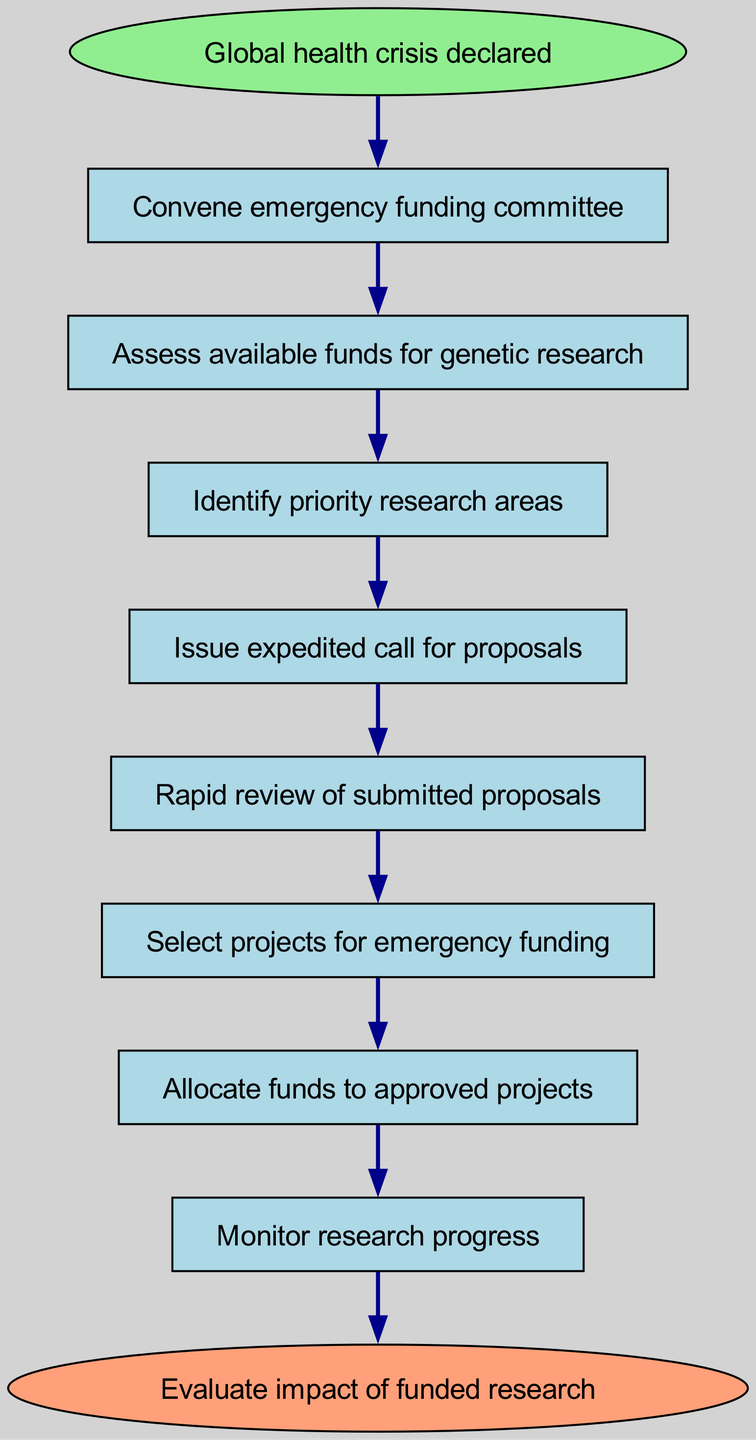What is the first step in the process? The first step in the process is represented by the "start" node, which states "Global health crisis declared." This is the initial action that triggers the further steps outlined in the flowchart.
Answer: Global health crisis declared How many steps are there in total? To find the total number of steps, we count all the nodes excluding the start and end nodes. The sequential steps include nodes from 1 to 8, leading to a total of 8 steps.
Answer: 8 What is the last action in the procedure? The last action in the procedure is captured in the "end" node, which states "Evaluate impact of funded research." This signifies the conclusion of the process.
Answer: Evaluate impact of funded research Which step comes after issuing a call for proposals? After issuing the call for proposals in step 4, the next step (step 5) is "Rapid review of submitted proposals." This shows the sequential nature of the funding process post-call issuance.
Answer: Rapid review of submitted proposals What is the relationship between the "Select projects for emergency funding" and "Allocate funds to approved projects"? The relationship between these two steps indicates a sequential flow: after selecting projects for emergency funding (step 6), the next action is to allocate resources to those approved projects (step 7). This highlights the logical progression from decision-making to funding distribution.
Answer: Sequential flow In which step is the emergency funding committee convened? The emergency funding committee is convened in step 1, right after the declaration of a global health crisis. This action is necessary to assess and manage available resources.
Answer: Step 1 How many nodes represent actions taken to disperse funds? The nodes that represent actions taken to disperse funds are step 6 (Select projects for emergency funding) and step 7 (Allocate funds to approved projects), resulting in a total of 2 nodes representing funding actions.
Answer: 2 What is the output of the "Monitor research progress" step? The "Monitor research progress" step (step 8) serves as an oversight action, tracking how the funded research is advancing, ultimately feeding into the evaluation of the funded research impact in the final step.
Answer: Oversight action 